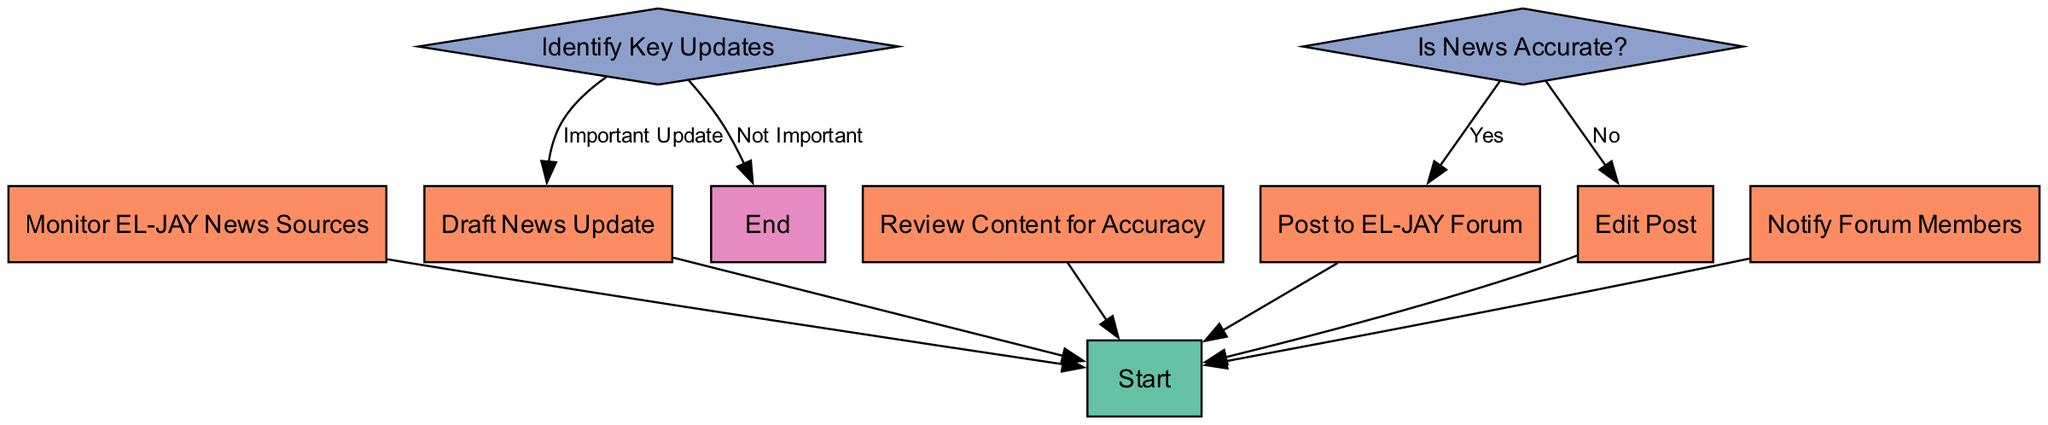What is the first step in the process? The first step shown in the diagram is labeled "Start," indicating the beginning of the process for compiling and sharing EL-JAY news.
Answer: Start How many decision nodes are present in the diagram? There are two decision nodes in the diagram: "Identify Key Updates" and "Is News Accurate?" which allow for two different paths to be followed based on conditions.
Answer: 2 What happens if the news is found to be not important? If the news is found to be not important based on the decision node "Identify Key Updates," the flow leads directly to the "End" node, indicating that the process concludes without further action.
Answer: End What step follows "Draft News Update"? After "Draft News Update," the next step is "Review Content for Accuracy" where the drafted content is checked for correctness before proceeding.
Answer: Review Content for Accuracy What is the outcome if the news is accurate after review? If the news is found to be accurate according to the decision node "Is News Accurate?", the next step is to "Post to EL-JAY Forum," meaning the news will be shared with the forum members.
Answer: Post to EL-JAY Forum If the news is not accurate, which step follows? If the news is not accurate, the subsequent step is "Edit Post," indicating that corrections need to be made before the news can be shared.
Answer: Edit Post What is the last action taken before the process ends? The last action taken before reaching the end of the process is "Notify Forum Members," which ensures that forum participants are informed about the new update after posting.
Answer: Notify Forum Members 